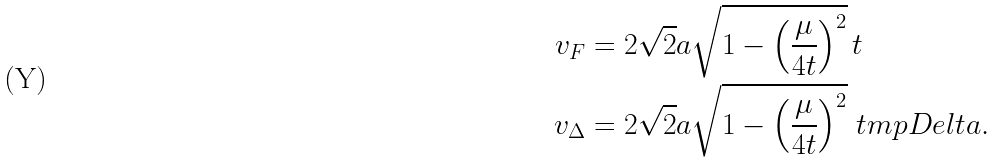<formula> <loc_0><loc_0><loc_500><loc_500>v _ { F } & = 2 \sqrt { 2 } a \sqrt { 1 - \left ( \frac { \mu } { 4 t } \right ) ^ { 2 } } \, t \\ v _ { \Delta } & = 2 \sqrt { 2 } a \sqrt { 1 - \left ( \frac { \mu } { 4 t } \right ) ^ { 2 } } \ t m p D e l t a .</formula> 